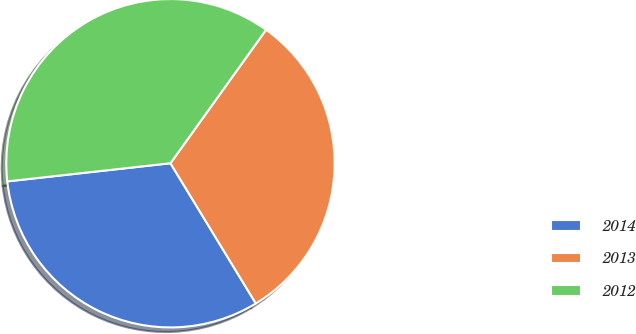Convert chart to OTSL. <chart><loc_0><loc_0><loc_500><loc_500><pie_chart><fcel>2014<fcel>2013<fcel>2012<nl><fcel>31.94%<fcel>31.4%<fcel>36.66%<nl></chart> 